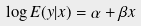Convert formula to latex. <formula><loc_0><loc_0><loc_500><loc_500>\log E ( y | x ) = \alpha + \beta x</formula> 